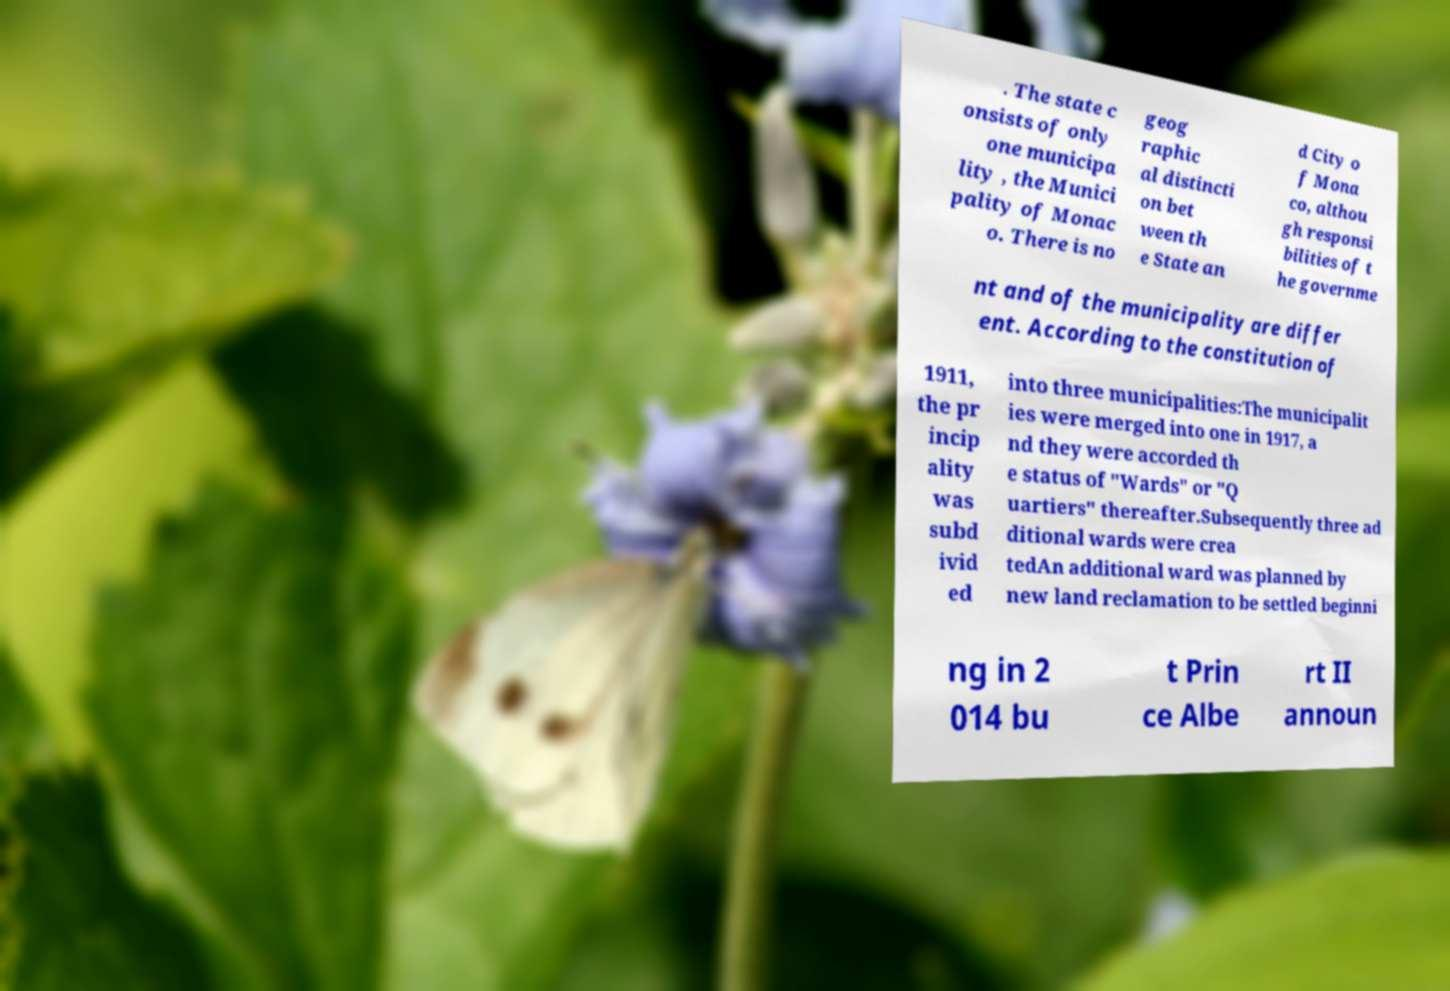I need the written content from this picture converted into text. Can you do that? . The state c onsists of only one municipa lity , the Munici pality of Monac o. There is no geog raphic al distincti on bet ween th e State an d City o f Mona co, althou gh responsi bilities of t he governme nt and of the municipality are differ ent. According to the constitution of 1911, the pr incip ality was subd ivid ed into three municipalities:The municipalit ies were merged into one in 1917, a nd they were accorded th e status of "Wards" or "Q uartiers" thereafter.Subsequently three ad ditional wards were crea tedAn additional ward was planned by new land reclamation to be settled beginni ng in 2 014 bu t Prin ce Albe rt II announ 